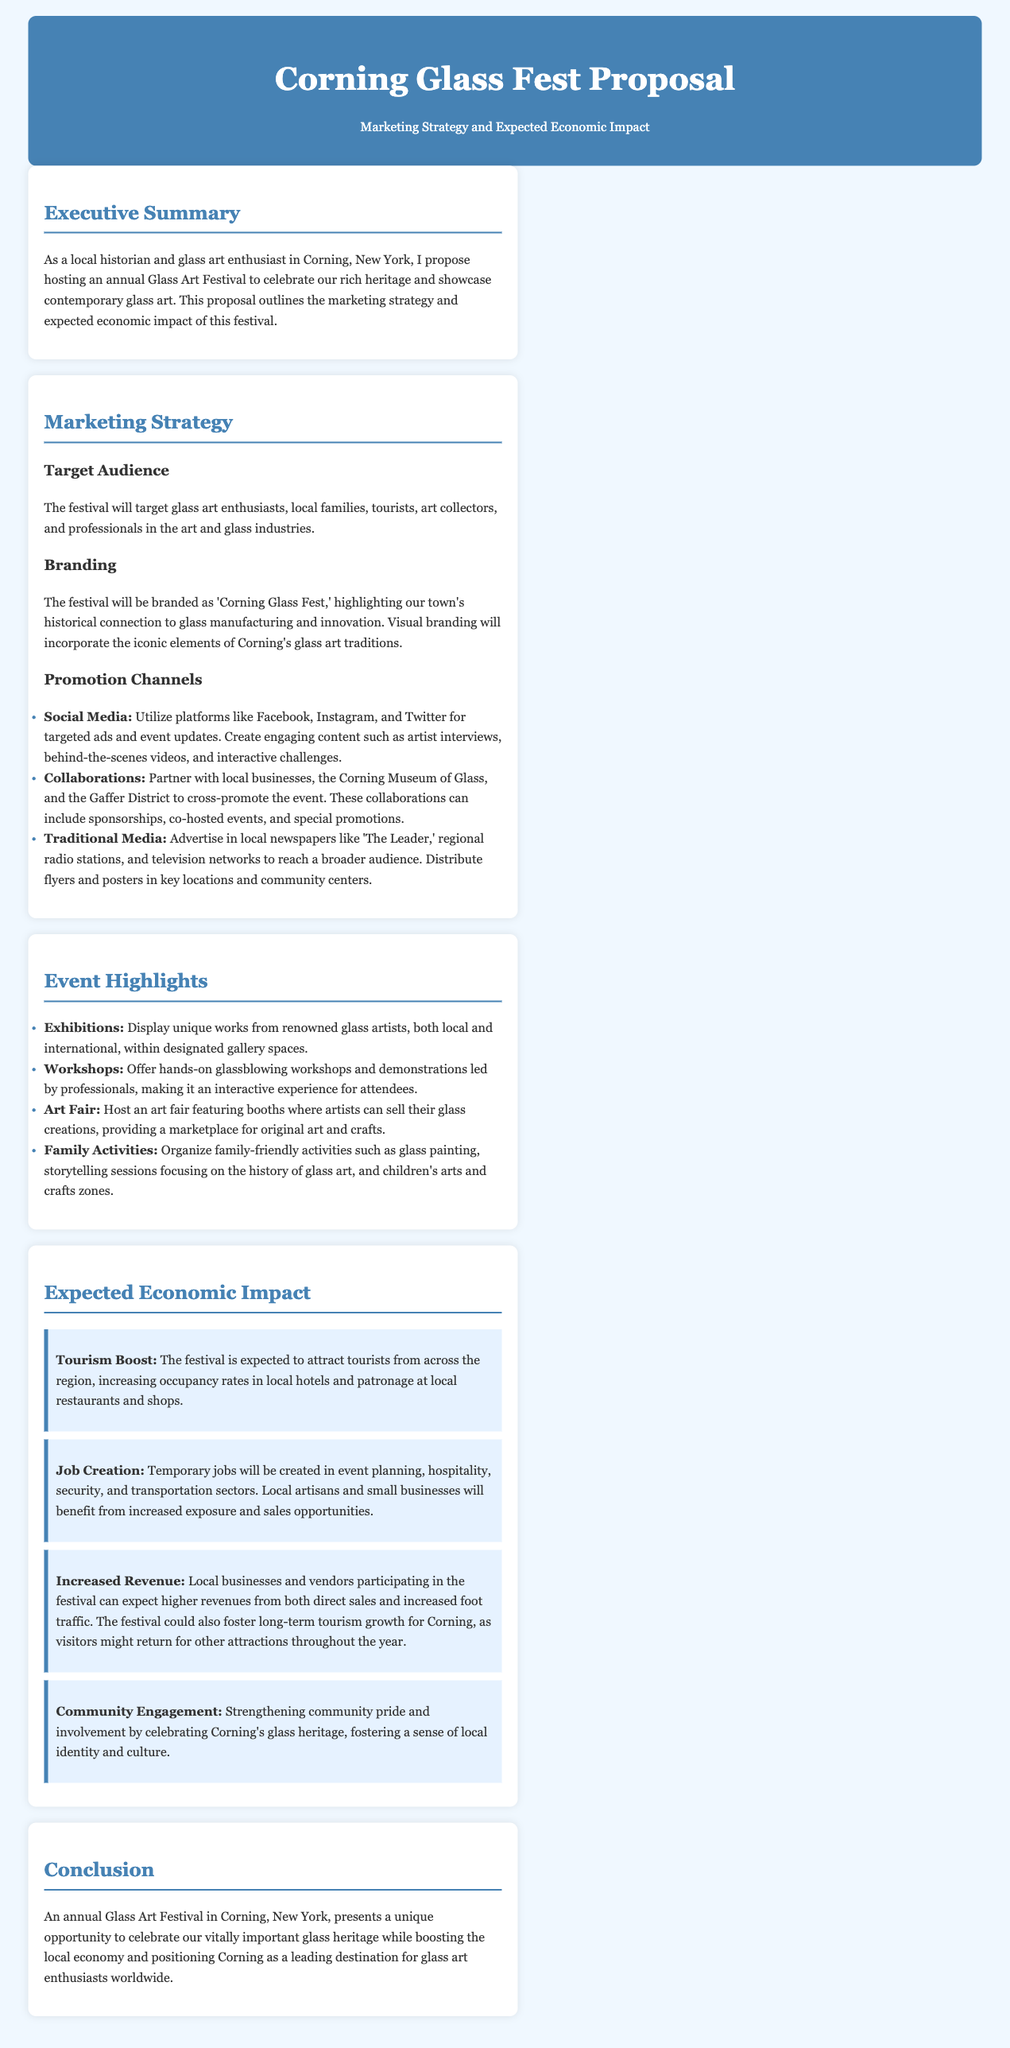What is the name of the festival? The document explicitly states the name of the festival as 'Corning Glass Fest.'
Answer: Corning Glass Fest What is the target audience for the festival? The proposal lists the target audience as glass art enthusiasts, local families, tourists, art collectors, and professionals in the art and glass industries.
Answer: Glass art enthusiasts, local families, tourists, art collectors, professionals What will be one of the exhibition features? The document mentions that unique works from renowned glass artists will be displayed within designated gallery spaces.
Answer: Unique works from renowned glass artists What is one promotion channel mentioned in the marketing strategy? The proposal provides several promotion channels, one of which is social media platforms like Facebook, Instagram, and Twitter.
Answer: Social media What is the expected tourism impact of the festival? The proposal states that the festival is expected to attract tourists from across the region, increasing occupancy rates in local hotels.
Answer: Increasing occupancy rates in local hotels What type of activities will be offered for families? The document lists family-friendly activities including glass painting, storytelling sessions, and arts and crafts zones.
Answer: Glass painting, storytelling sessions, arts and crafts zones How does the festival aim to impact local businesses? The expected economic impact includes higher revenues from both direct sales and increased foot traffic for local businesses and vendors.
Answer: Higher revenues from direct sales and increased foot traffic What is a key goal of the annual Glass Art Festival? A key goal of the festival is to celebrate Corning's glass heritage while boosting the local economy.
Answer: Celebrate Corning's glass heritage, boost local economy How will workshops be structured at the festival? The proposal indicates that workshops will be hands-on glassblowing sessions led by professionals.
Answer: Hands-on glassblowing workshops led by professionals 